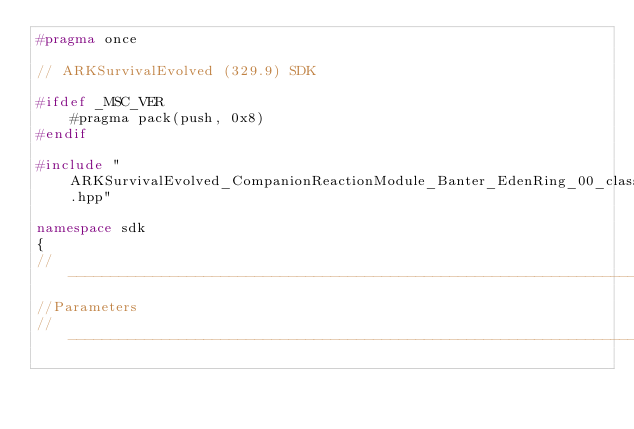<code> <loc_0><loc_0><loc_500><loc_500><_C++_>#pragma once

// ARKSurvivalEvolved (329.9) SDK

#ifdef _MSC_VER
	#pragma pack(push, 0x8)
#endif

#include "ARKSurvivalEvolved_CompanionReactionModule_Banter_EdenRing_00_classes.hpp"

namespace sdk
{
//---------------------------------------------------------------------------
//Parameters
//---------------------------------------------------------------------------
</code> 